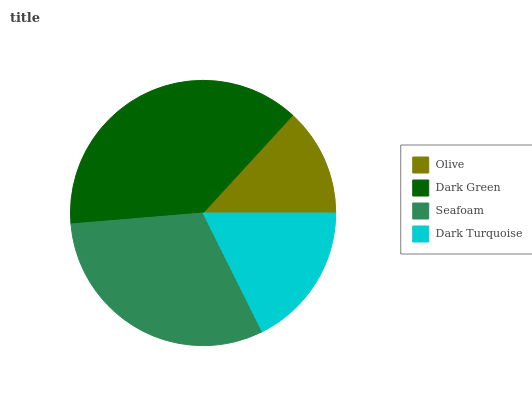Is Olive the minimum?
Answer yes or no. Yes. Is Dark Green the maximum?
Answer yes or no. Yes. Is Seafoam the minimum?
Answer yes or no. No. Is Seafoam the maximum?
Answer yes or no. No. Is Dark Green greater than Seafoam?
Answer yes or no. Yes. Is Seafoam less than Dark Green?
Answer yes or no. Yes. Is Seafoam greater than Dark Green?
Answer yes or no. No. Is Dark Green less than Seafoam?
Answer yes or no. No. Is Seafoam the high median?
Answer yes or no. Yes. Is Dark Turquoise the low median?
Answer yes or no. Yes. Is Dark Turquoise the high median?
Answer yes or no. No. Is Seafoam the low median?
Answer yes or no. No. 